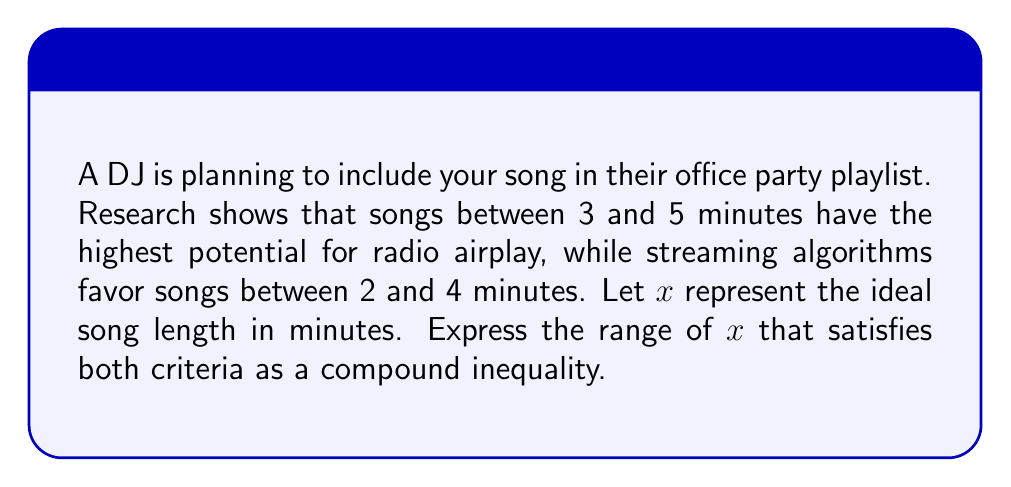Teach me how to tackle this problem. To solve this problem, we need to find the intersection of the two given ranges:

1. Radio airplay potential: $3 \leq x \leq 5$
2. Streaming algorithm preferences: $2 \leq x \leq 4$

To satisfy both criteria, we need to find the values of $x$ that fall within both ranges simultaneously.

The lower bound of $x$ will be the larger of the two lower bounds:
$\max(3, 2) = 3$

The upper bound of $x$ will be the smaller of the two upper bounds:
$\min(5, 4) = 4$

Therefore, the range of $x$ that satisfies both criteria can be expressed as:

$$3 \leq x \leq 4$$

This compound inequality represents the ideal song length range in minutes that balances both radio airplay potential and streaming algorithm preferences.
Answer: $3 \leq x \leq 4$ 